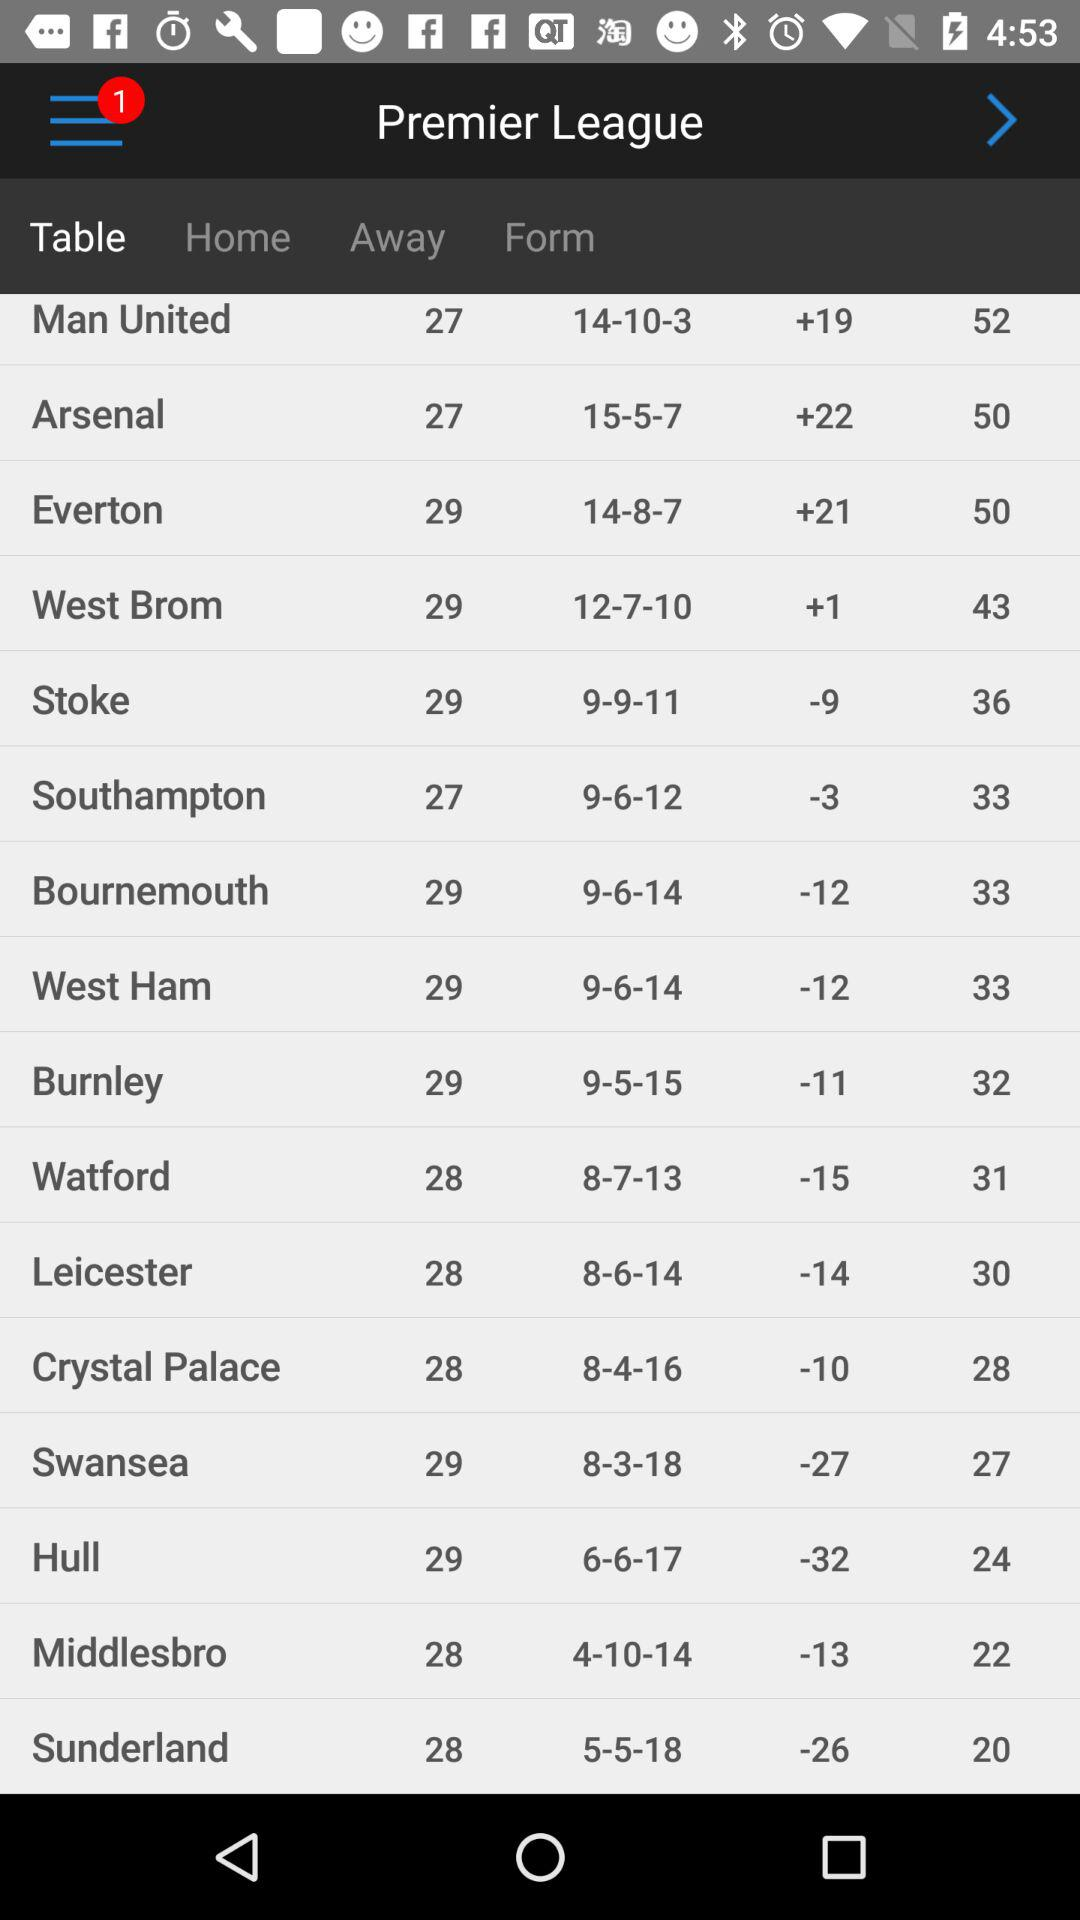How many new notifications are there? There is 1 new notification. 